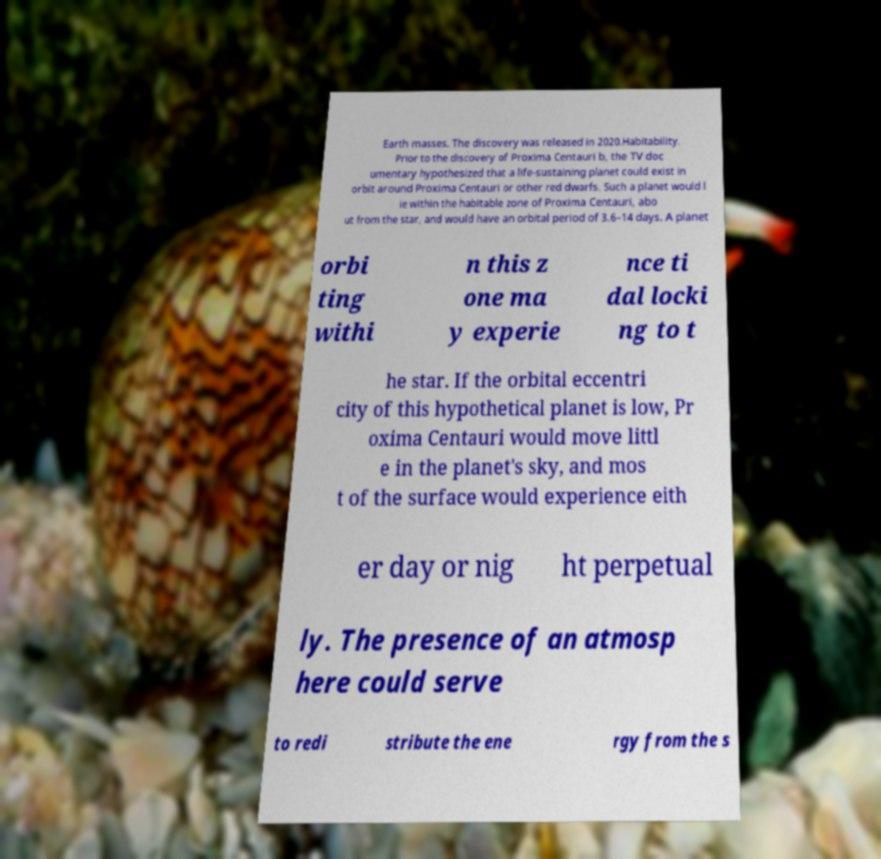For documentation purposes, I need the text within this image transcribed. Could you provide that? Earth masses. The discovery was released in 2020.Habitability. Prior to the discovery of Proxima Centauri b, the TV doc umentary hypothesized that a life-sustaining planet could exist in orbit around Proxima Centauri or other red dwarfs. Such a planet would l ie within the habitable zone of Proxima Centauri, abo ut from the star, and would have an orbital period of 3.6–14 days. A planet orbi ting withi n this z one ma y experie nce ti dal locki ng to t he star. If the orbital eccentri city of this hypothetical planet is low, Pr oxima Centauri would move littl e in the planet's sky, and mos t of the surface would experience eith er day or nig ht perpetual ly. The presence of an atmosp here could serve to redi stribute the ene rgy from the s 